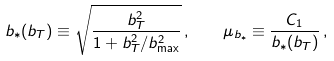<formula> <loc_0><loc_0><loc_500><loc_500>b _ { * } ( b _ { T } ) \equiv \sqrt { \frac { b _ { T } ^ { 2 } } { 1 + b _ { T } ^ { 2 } / b _ { \max } ^ { 2 } } } \, , \quad \mu _ { b _ { * } } \equiv \frac { C _ { 1 } } { b _ { * } ( b _ { T } ) } \, ,</formula> 